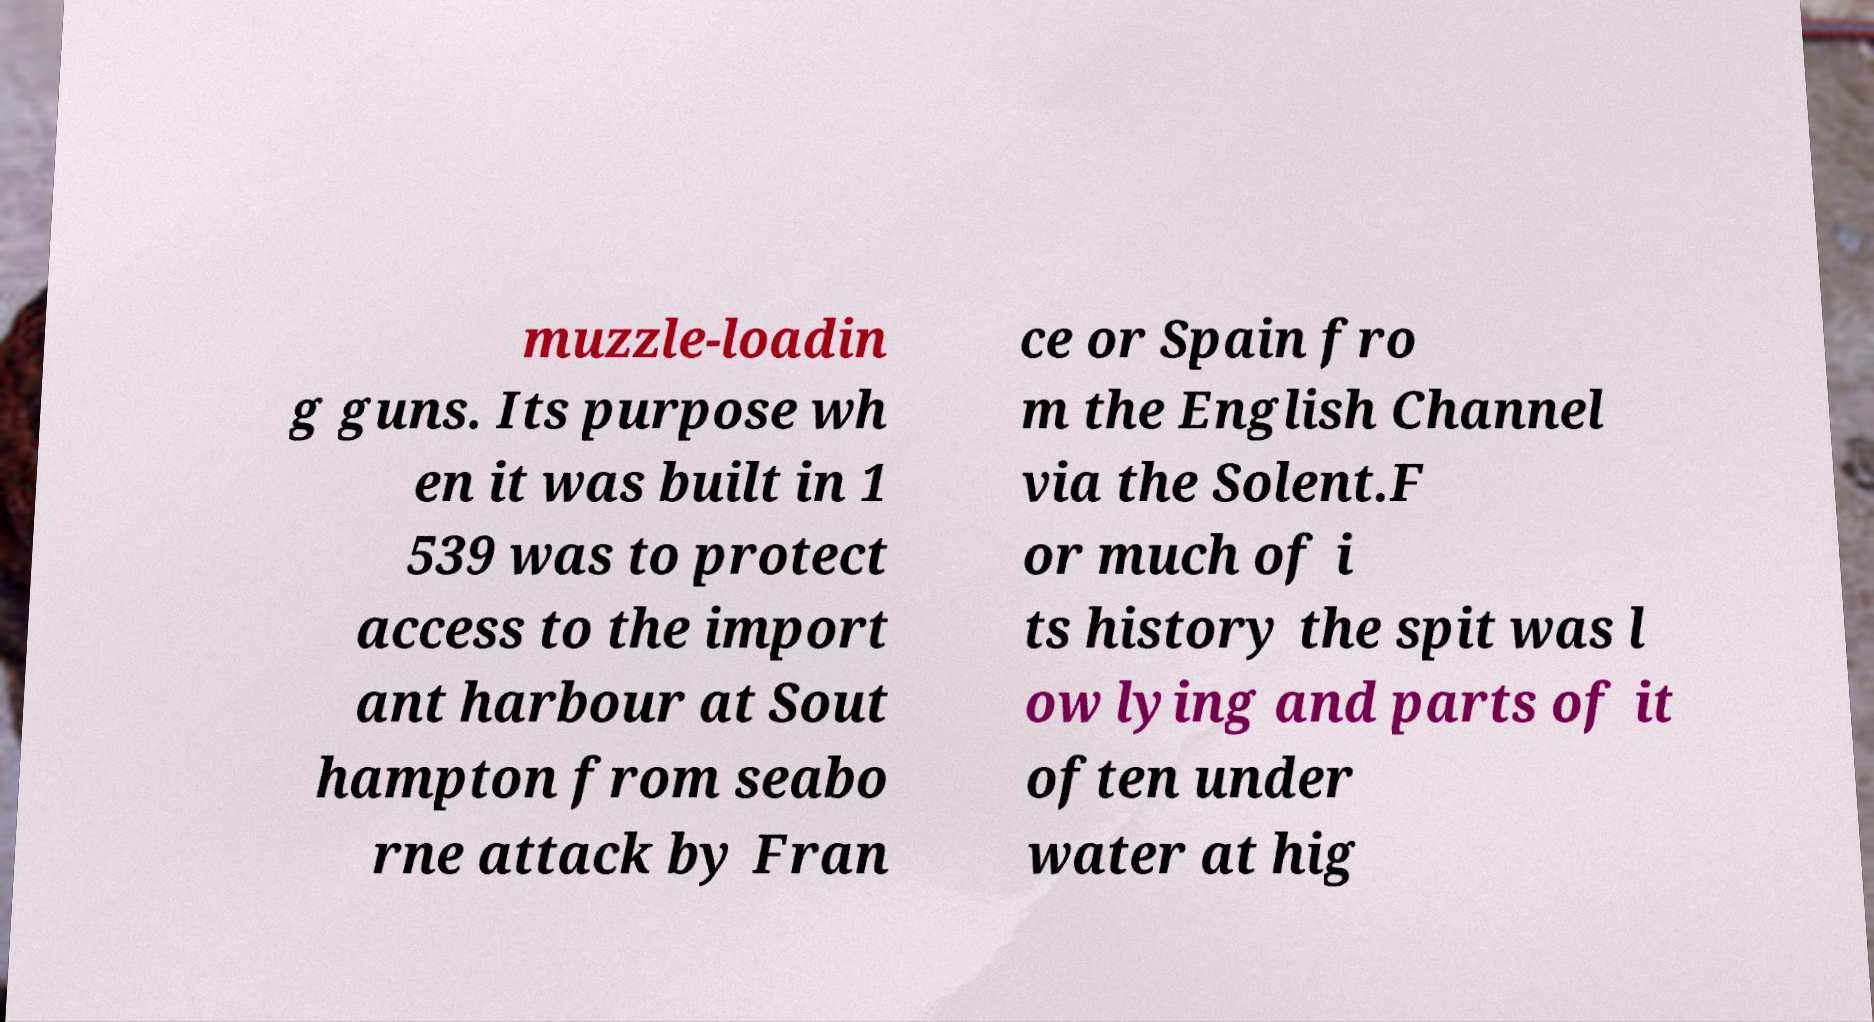Please read and relay the text visible in this image. What does it say? muzzle-loadin g guns. Its purpose wh en it was built in 1 539 was to protect access to the import ant harbour at Sout hampton from seabo rne attack by Fran ce or Spain fro m the English Channel via the Solent.F or much of i ts history the spit was l ow lying and parts of it often under water at hig 